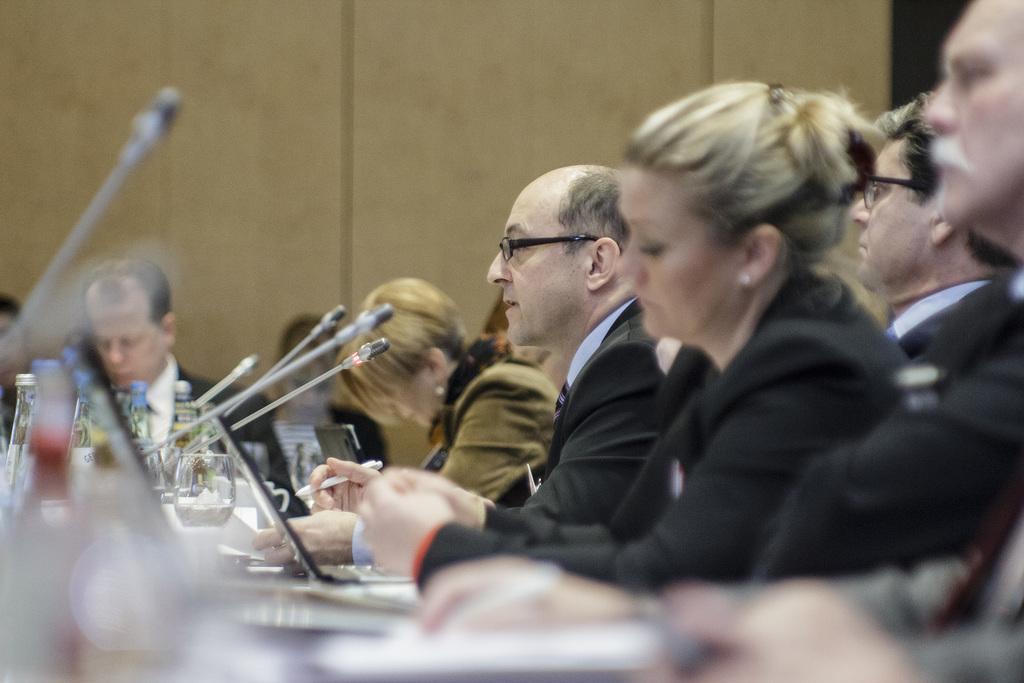In one or two sentences, can you explain what this image depicts? In this image I can see on the right side a group of people are there, they are wearing black color coats. On the left side there are microphones, in the middle there is a laptop. 